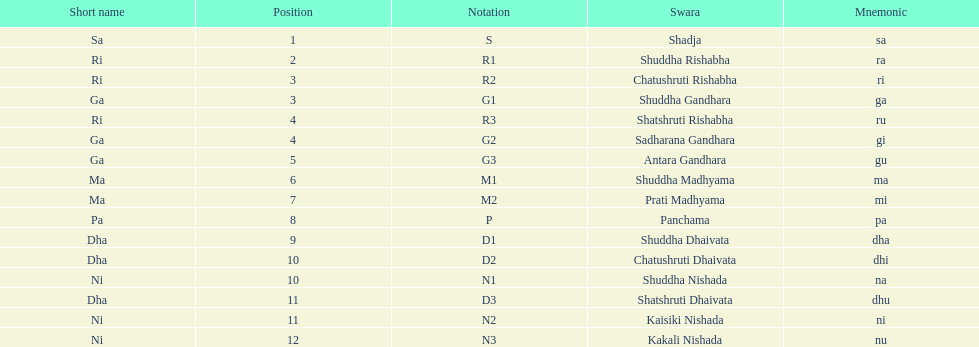How many swaras do not have dhaivata in their name? 13. 